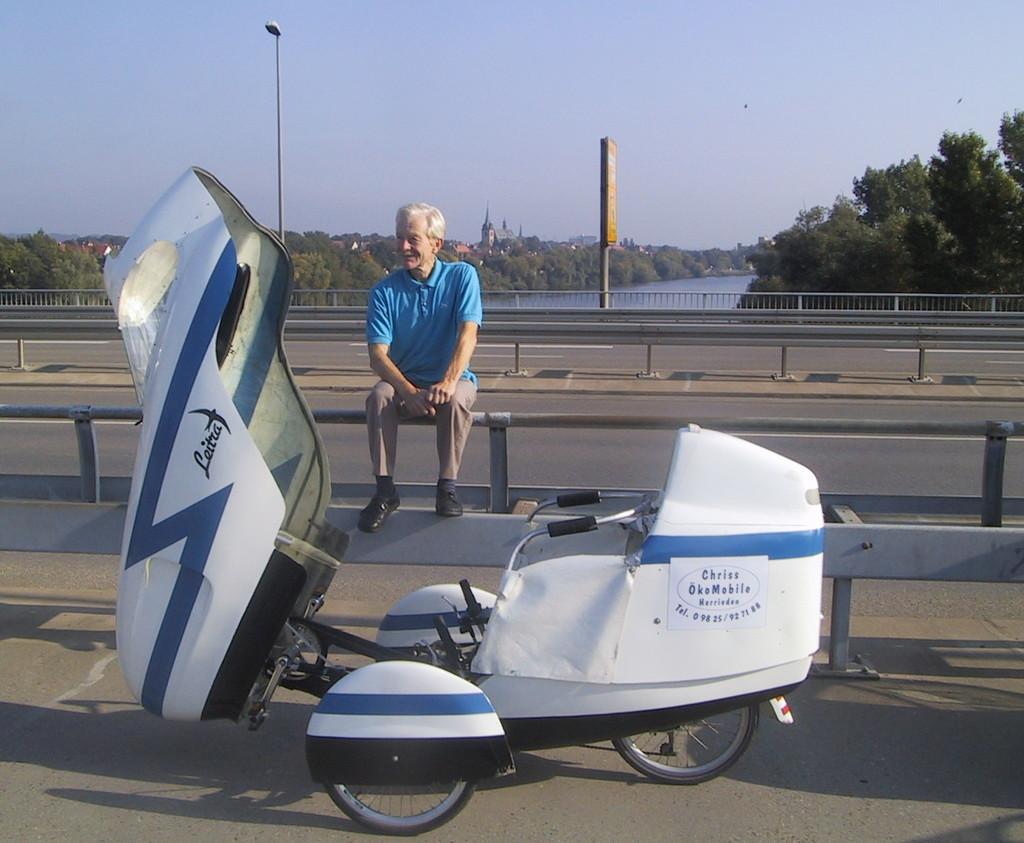Whose okomobile is this?
Keep it short and to the point. Chriss. What brand the okomobile?
Provide a short and direct response. Leitra. 